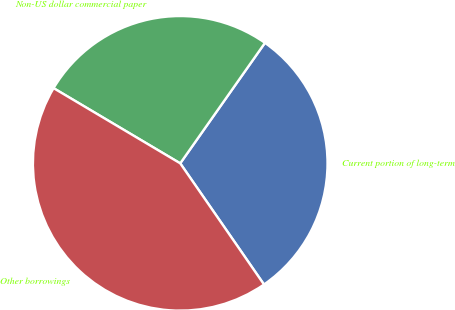Convert chart to OTSL. <chart><loc_0><loc_0><loc_500><loc_500><pie_chart><fcel>Current portion of long-term<fcel>Non-US dollar commercial paper<fcel>Other borrowings<nl><fcel>30.62%<fcel>26.23%<fcel>43.16%<nl></chart> 